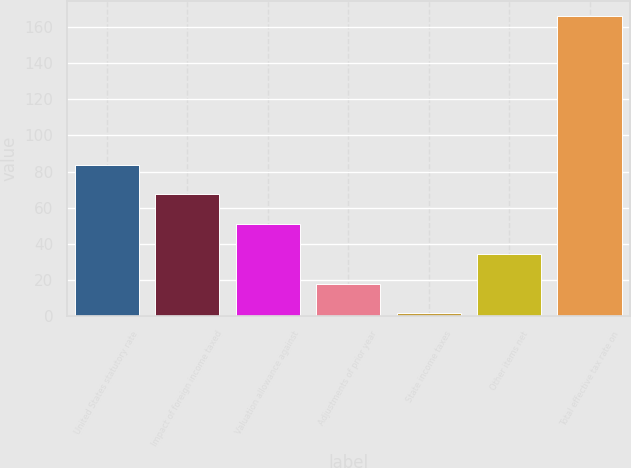<chart> <loc_0><loc_0><loc_500><loc_500><bar_chart><fcel>United States statutory rate<fcel>Impact of foreign income taxed<fcel>Valuation allowance against<fcel>Adjustments of prior year<fcel>State income taxes<fcel>Other items net<fcel>Total effective tax rate on<nl><fcel>83.75<fcel>67.34<fcel>50.93<fcel>18.11<fcel>1.7<fcel>34.52<fcel>165.8<nl></chart> 